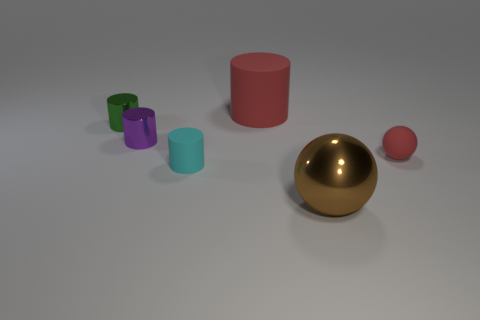Subtract all green metal cylinders. How many cylinders are left? 3 Subtract all cylinders. How many objects are left? 2 Subtract 1 cylinders. How many cylinders are left? 3 Subtract all cyan balls. Subtract all tiny green cylinders. How many objects are left? 5 Add 4 red objects. How many red objects are left? 6 Add 2 small spheres. How many small spheres exist? 3 Add 2 small purple metal cylinders. How many objects exist? 8 Subtract all brown spheres. How many spheres are left? 1 Subtract 0 yellow cubes. How many objects are left? 6 Subtract all blue balls. Subtract all yellow cubes. How many balls are left? 2 